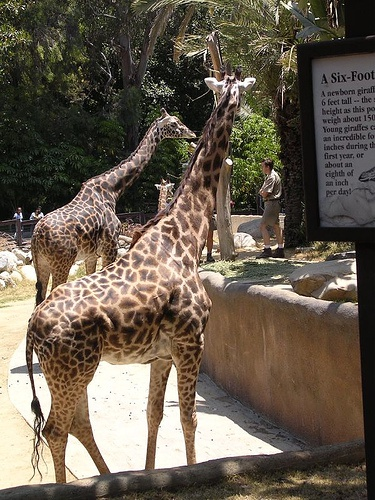Describe the objects in this image and their specific colors. I can see giraffe in black, gray, and maroon tones, giraffe in black, gray, and darkgray tones, people in black, gray, and maroon tones, giraffe in black, tan, ivory, gray, and darkgray tones, and people in black, gray, and lightgray tones in this image. 